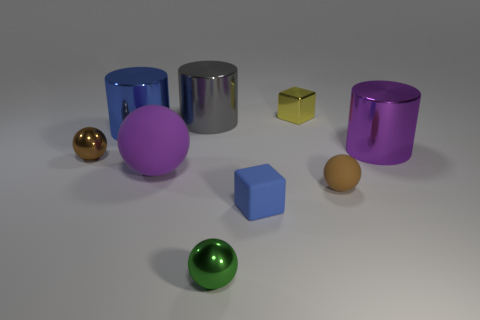Subtract all yellow spheres. Subtract all gray cubes. How many spheres are left? 4 Add 1 big green metal spheres. How many objects exist? 10 Subtract all blocks. How many objects are left? 7 Add 4 small spheres. How many small spheres exist? 7 Subtract 0 cyan spheres. How many objects are left? 9 Subtract all small brown metal balls. Subtract all small metal blocks. How many objects are left? 7 Add 8 gray cylinders. How many gray cylinders are left? 9 